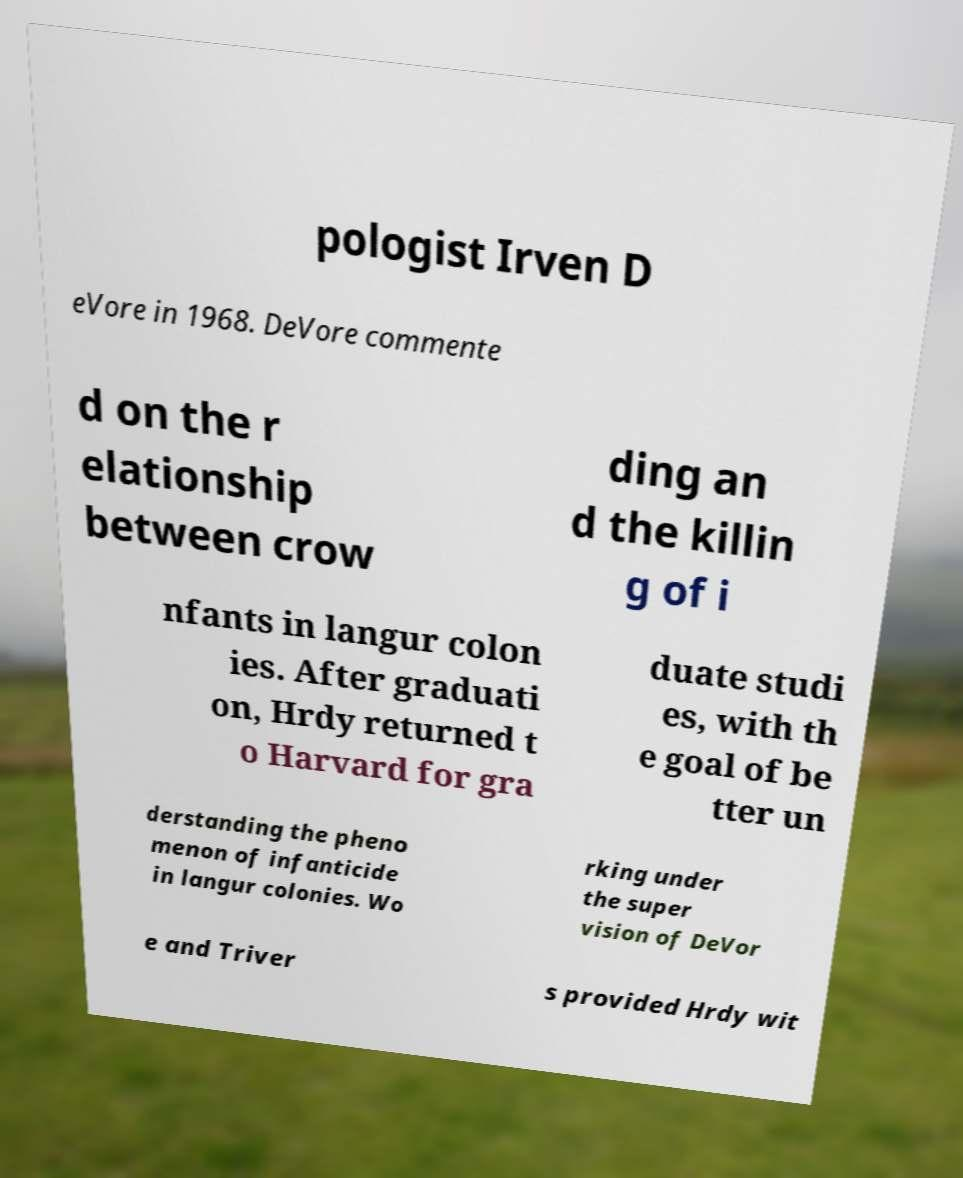What messages or text are displayed in this image? I need them in a readable, typed format. pologist Irven D eVore in 1968. DeVore commente d on the r elationship between crow ding an d the killin g of i nfants in langur colon ies. After graduati on, Hrdy returned t o Harvard for gra duate studi es, with th e goal of be tter un derstanding the pheno menon of infanticide in langur colonies. Wo rking under the super vision of DeVor e and Triver s provided Hrdy wit 